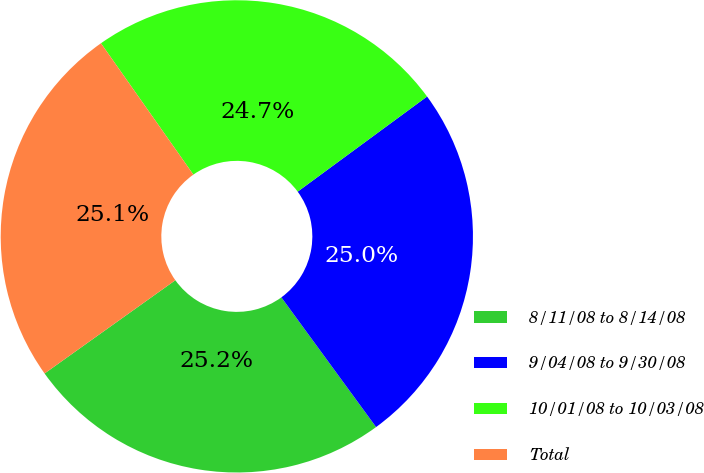<chart> <loc_0><loc_0><loc_500><loc_500><pie_chart><fcel>8/11/08 to 8/14/08<fcel>9/04/08 to 9/30/08<fcel>10/01/08 to 10/03/08<fcel>Total<nl><fcel>25.18%<fcel>25.05%<fcel>24.67%<fcel>25.1%<nl></chart> 